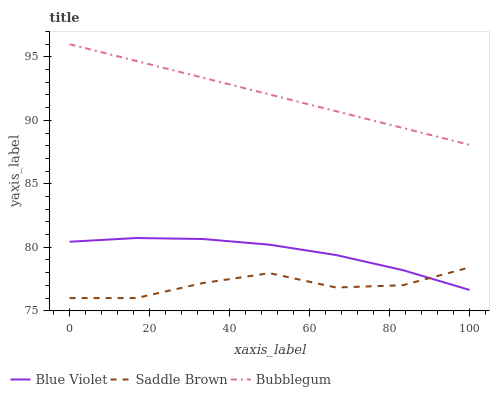Does Saddle Brown have the minimum area under the curve?
Answer yes or no. Yes. Does Bubblegum have the maximum area under the curve?
Answer yes or no. Yes. Does Blue Violet have the minimum area under the curve?
Answer yes or no. No. Does Blue Violet have the maximum area under the curve?
Answer yes or no. No. Is Bubblegum the smoothest?
Answer yes or no. Yes. Is Saddle Brown the roughest?
Answer yes or no. Yes. Is Blue Violet the smoothest?
Answer yes or no. No. Is Blue Violet the roughest?
Answer yes or no. No. Does Saddle Brown have the lowest value?
Answer yes or no. Yes. Does Blue Violet have the lowest value?
Answer yes or no. No. Does Bubblegum have the highest value?
Answer yes or no. Yes. Does Blue Violet have the highest value?
Answer yes or no. No. Is Blue Violet less than Bubblegum?
Answer yes or no. Yes. Is Bubblegum greater than Blue Violet?
Answer yes or no. Yes. Does Saddle Brown intersect Blue Violet?
Answer yes or no. Yes. Is Saddle Brown less than Blue Violet?
Answer yes or no. No. Is Saddle Brown greater than Blue Violet?
Answer yes or no. No. Does Blue Violet intersect Bubblegum?
Answer yes or no. No. 